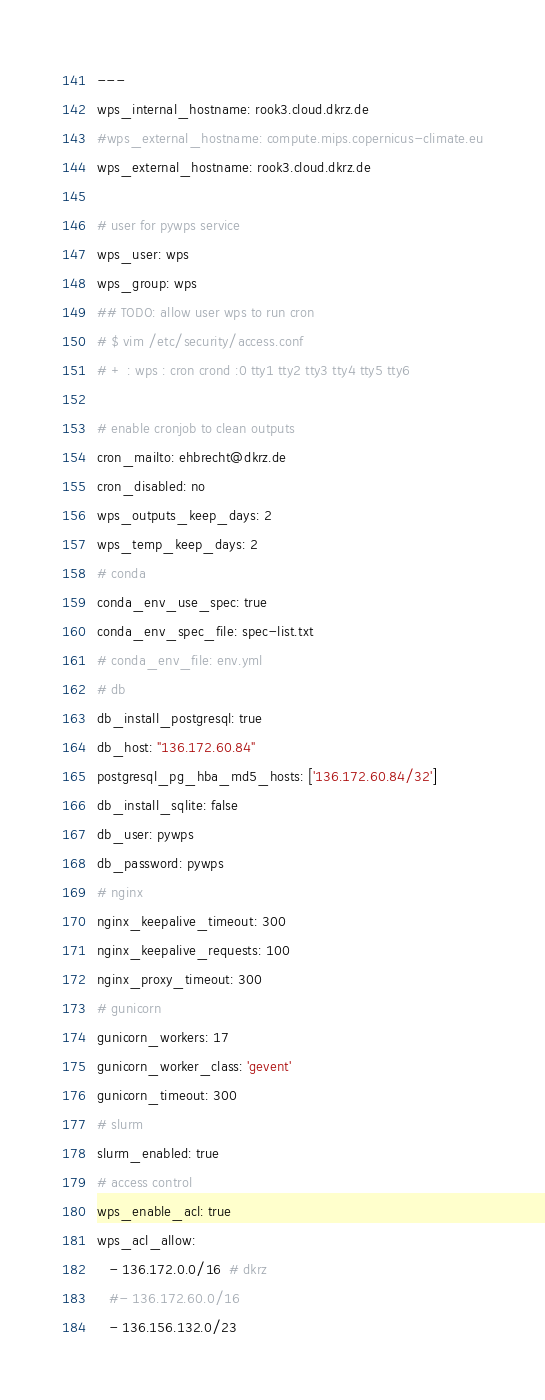Convert code to text. <code><loc_0><loc_0><loc_500><loc_500><_YAML_>---
wps_internal_hostname: rook3.cloud.dkrz.de
#wps_external_hostname: compute.mips.copernicus-climate.eu
wps_external_hostname: rook3.cloud.dkrz.de

# user for pywps service
wps_user: wps
wps_group: wps
## TODO: allow user wps to run cron
# $ vim /etc/security/access.conf
# + : wps : cron crond :0 tty1 tty2 tty3 tty4 tty5 tty6

# enable cronjob to clean outputs
cron_mailto: ehbrecht@dkrz.de
cron_disabled: no
wps_outputs_keep_days: 2 
wps_temp_keep_days: 2
# conda
conda_env_use_spec: true
conda_env_spec_file: spec-list.txt
# conda_env_file: env.yml
# db
db_install_postgresql: true
db_host: "136.172.60.84"
postgresql_pg_hba_md5_hosts: ['136.172.60.84/32']
db_install_sqlite: false
db_user: pywps
db_password: pywps
# nginx
nginx_keepalive_timeout: 300
nginx_keepalive_requests: 100
nginx_proxy_timeout: 300
# gunicorn
gunicorn_workers: 17
gunicorn_worker_class: 'gevent'
gunicorn_timeout: 300
# slurm
slurm_enabled: true
# access control
wps_enable_acl: true
wps_acl_allow:
   - 136.172.0.0/16  # dkrz
   #- 136.172.60.0/16  
   - 136.156.132.0/23</code> 